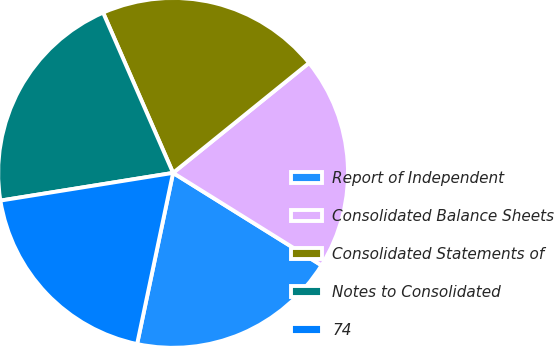Convert chart to OTSL. <chart><loc_0><loc_0><loc_500><loc_500><pie_chart><fcel>Report of Independent<fcel>Consolidated Balance Sheets<fcel>Consolidated Statements of<fcel>Notes to Consolidated<fcel>74<nl><fcel>19.43%<fcel>19.69%<fcel>20.73%<fcel>20.98%<fcel>19.17%<nl></chart> 